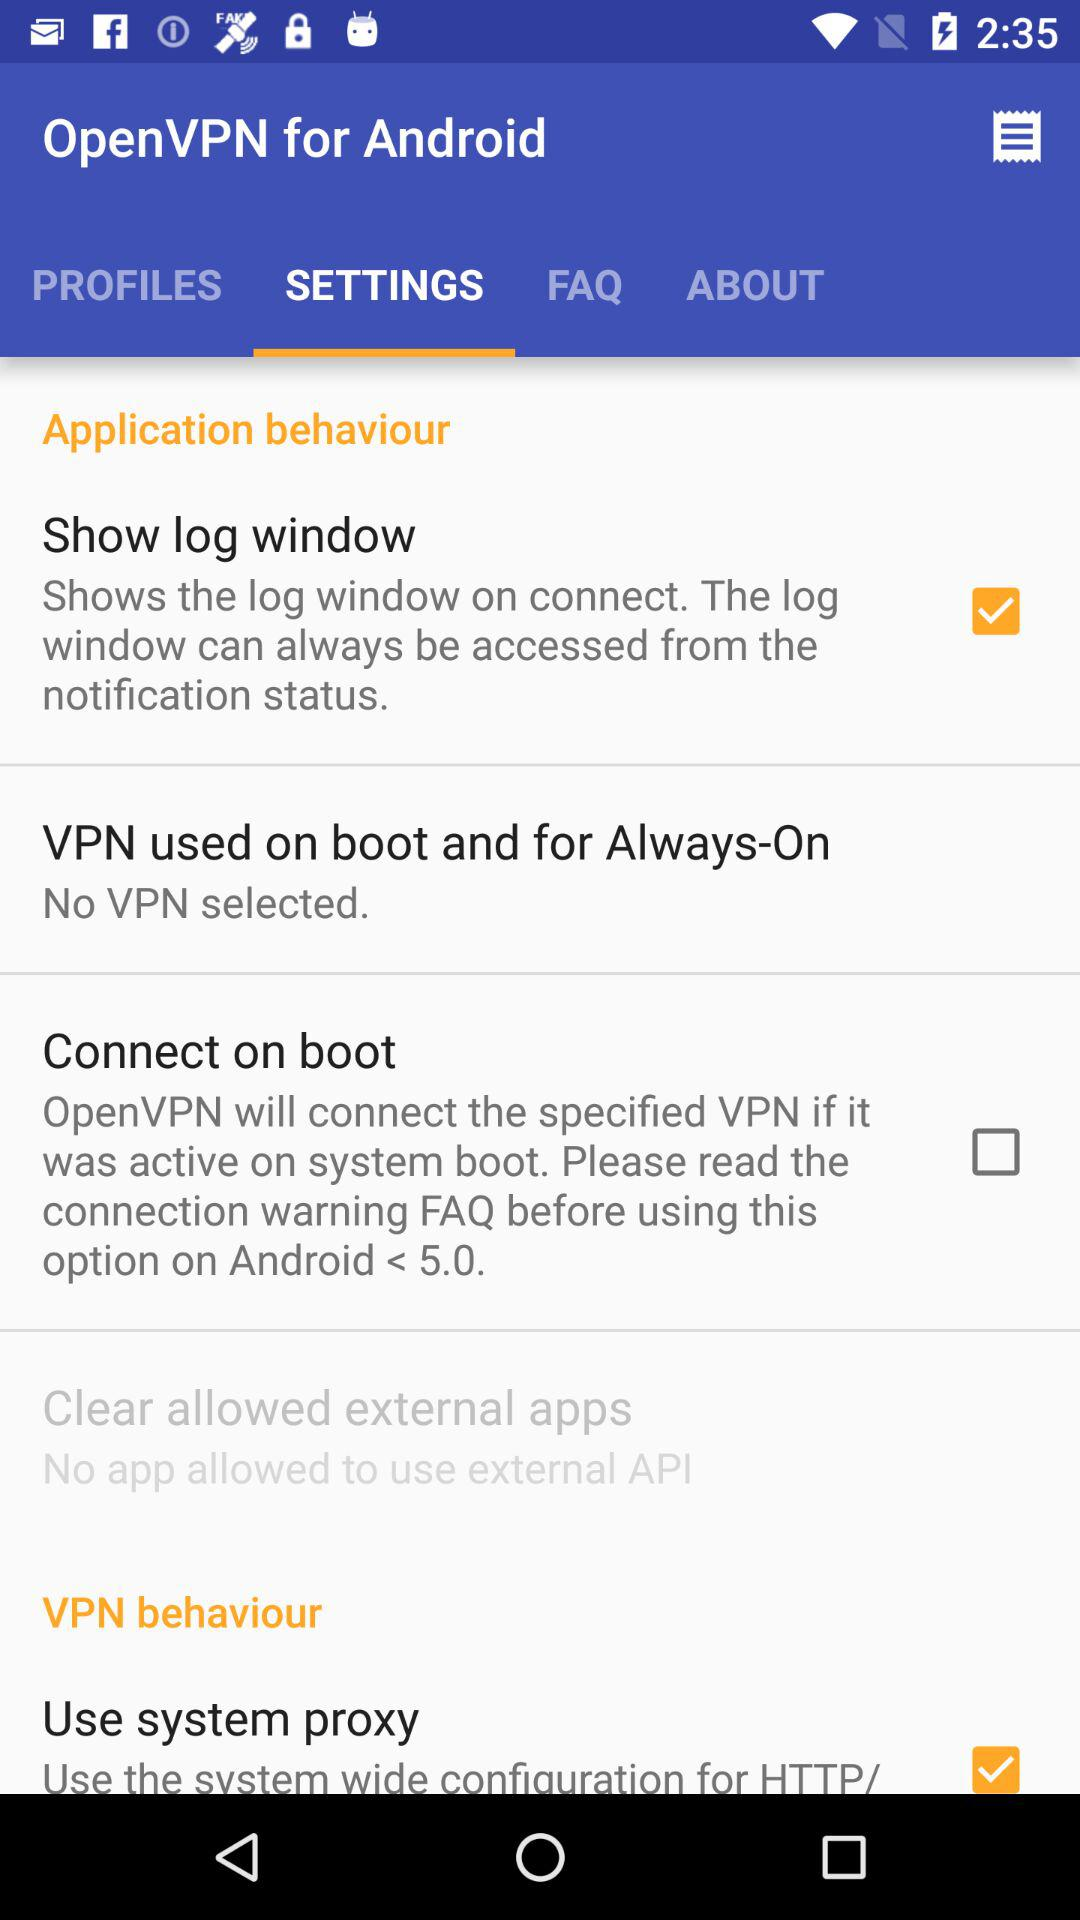How many items can be configured in the application behavior section?
Answer the question using a single word or phrase. 4 